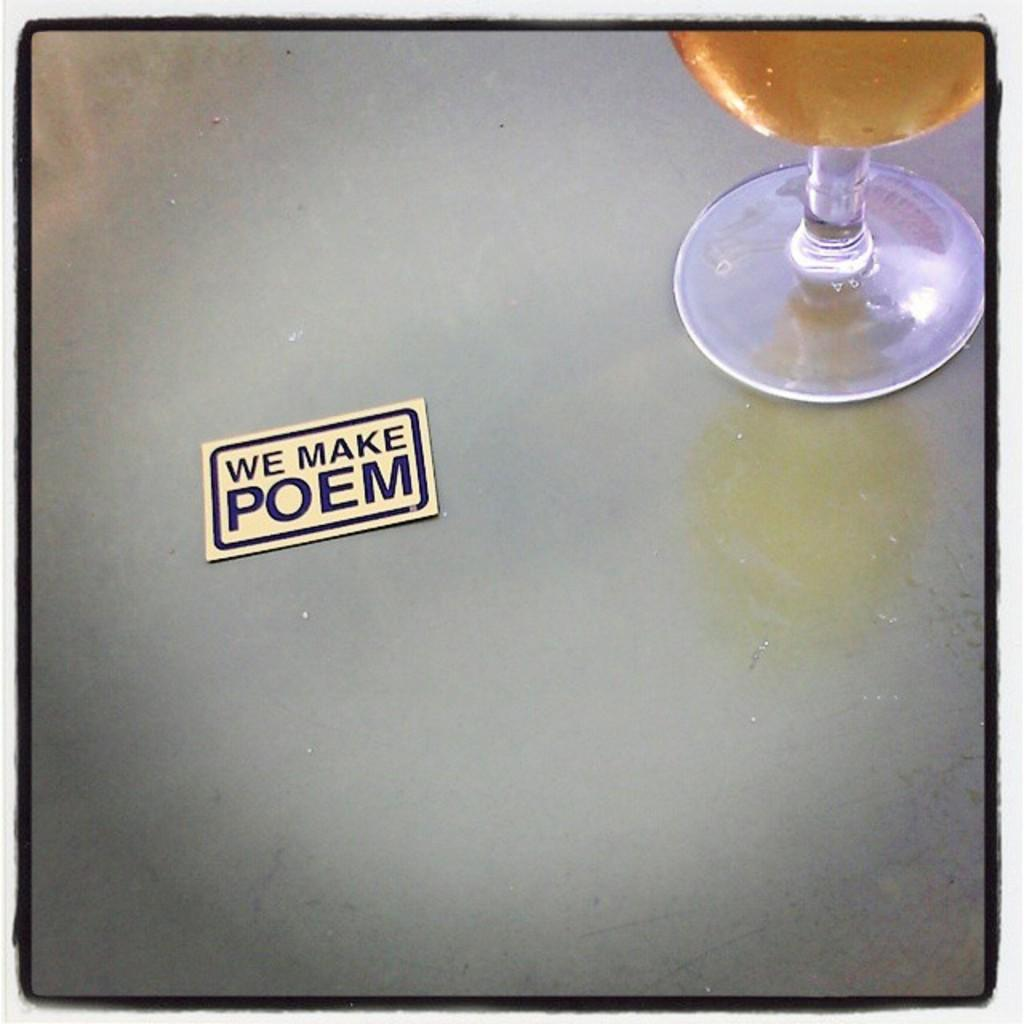<image>
Write a terse but informative summary of the picture. a sticker that reads we make poem on a silver table with a glass of amber liquid nearby 